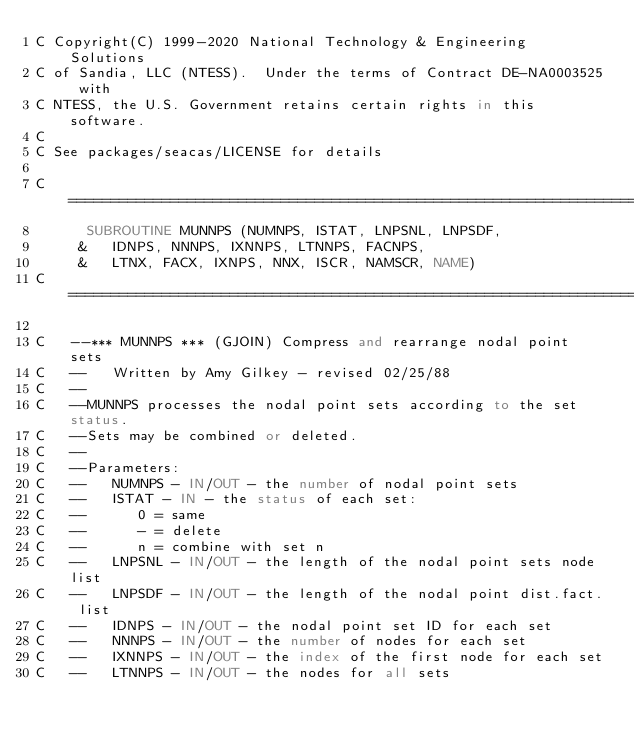Convert code to text. <code><loc_0><loc_0><loc_500><loc_500><_FORTRAN_>C Copyright(C) 1999-2020 National Technology & Engineering Solutions
C of Sandia, LLC (NTESS).  Under the terms of Contract DE-NA0003525 with
C NTESS, the U.S. Government retains certain rights in this software.
C
C See packages/seacas/LICENSE for details

C=======================================================================
      SUBROUTINE MUNNPS (NUMNPS, ISTAT, LNPSNL, LNPSDF,
     &   IDNPS, NNNPS, IXNNPS, LTNNPS, FACNPS,
     &   LTNX, FACX, IXNPS, NNX, ISCR, NAMSCR, NAME)
C=======================================================================

C   --*** MUNNPS *** (GJOIN) Compress and rearrange nodal point sets
C   --   Written by Amy Gilkey - revised 02/25/88
C   --
C   --MUNNPS processes the nodal point sets according to the set status.
C   --Sets may be combined or deleted.
C   --
C   --Parameters:
C   --   NUMNPS - IN/OUT - the number of nodal point sets
C   --   ISTAT - IN - the status of each set:
C   --      0 = same
C   --      - = delete
C   --      n = combine with set n
C   --   LNPSNL - IN/OUT - the length of the nodal point sets node list
C   --   LNPSDF - IN/OUT - the length of the nodal point dist.fact. list
C   --   IDNPS - IN/OUT - the nodal point set ID for each set
C   --   NNNPS - IN/OUT - the number of nodes for each set
C   --   IXNNPS - IN/OUT - the index of the first node for each set
C   --   LTNNPS - IN/OUT - the nodes for all sets</code> 